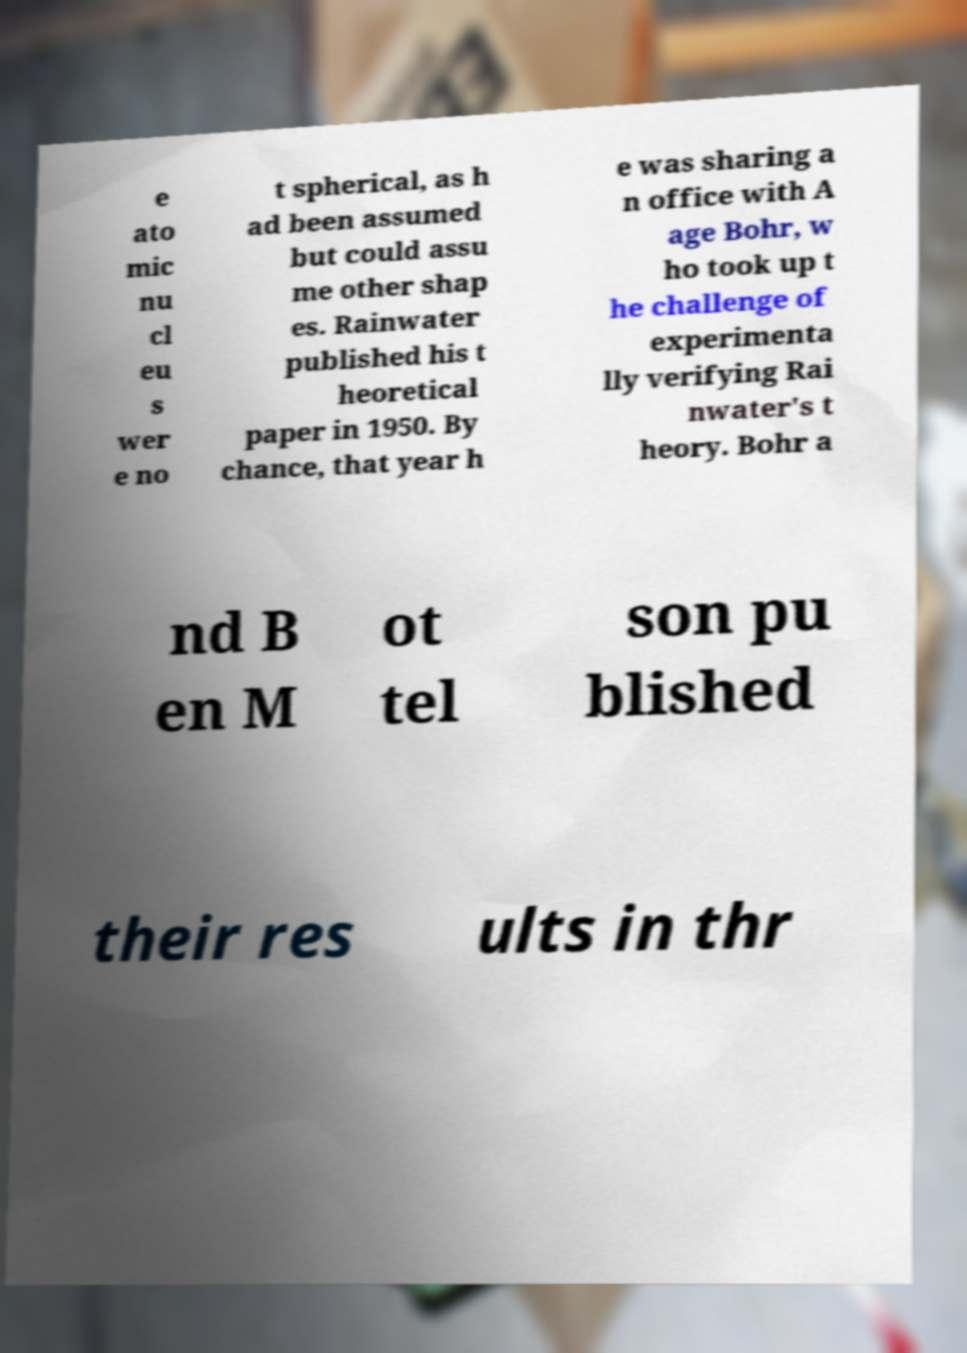Can you read and provide the text displayed in the image?This photo seems to have some interesting text. Can you extract and type it out for me? e ato mic nu cl eu s wer e no t spherical, as h ad been assumed but could assu me other shap es. Rainwater published his t heoretical paper in 1950. By chance, that year h e was sharing a n office with A age Bohr, w ho took up t he challenge of experimenta lly verifying Rai nwater's t heory. Bohr a nd B en M ot tel son pu blished their res ults in thr 